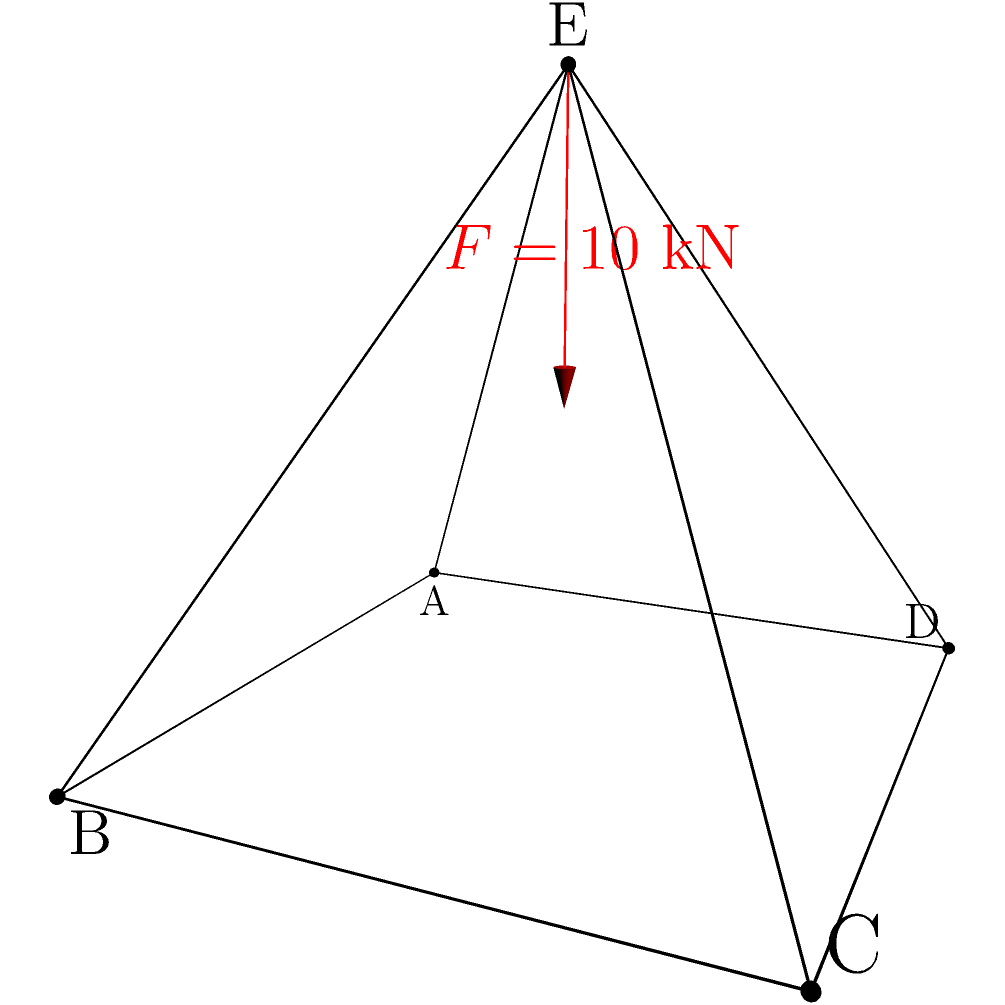Consider the space frame structure shown in the figure, where ABCD forms a square base of side length 3 meters, and point E is located 2 meters above the center of the square. A vertical force $F = 10$ kN is applied at point E, directed downwards. Using the method of virtual work, determine the vertical displacement of point E, assuming all members have the same cross-sectional area $A = 500$ mm² and Young's modulus $E = 200$ GPa. To solve this problem using the method of virtual work, we'll follow these steps:

1) First, we need to calculate the length of each member:
   Base members: $l_{AB} = l_{BC} = l_{CD} = l_{DA} = 3$ m
   Diagonal members: $l_{AE} = l_{BE} = l_{CE} = l_{DE} = \sqrt{3^2/2 + 2^2} = \sqrt{6.25} = 2.5$ m

2) Next, we'll apply a unit virtual force at point E in the direction of the displacement we want to calculate (vertical downward).

3) Now, we need to determine the axial forces in each member due to the real load (10 kN) and the virtual unit load.

   For the real load:
   Force in each diagonal member: $F_d = 10 / 4 = 2.5$ kN (tension)
   Force in base members: $F_b = 0$ kN

   For the virtual unit load:
   Virtual force in each diagonal member: $f_d = 1 / 4 = 0.25$ (tension)
   Virtual force in base members: $f_b = 0$

4) Apply the virtual work equation:
   $$\delta = \sum \frac{Ff l}{AE}$$
   where $\delta$ is the displacement, $F$ is the real force, $f$ is the virtual force, $l$ is the member length, $A$ is the cross-sectional area, and $E$ is Young's modulus.

5) Substituting the values:
   $$\delta = 4 \cdot \frac{2.5 \cdot 0.25 \cdot 2.5}{500 \cdot 10^{-6} \cdot 200 \cdot 10^9}$$

6) Simplify:
   $$\delta = 4 \cdot \frac{1.5625}{100 \cdot 10^6} = \frac{6.25}{100 \cdot 10^6} = 0.0625 \cdot 10^{-3} = 6.25 \cdot 10^{-5}$$ m

Therefore, the vertical displacement of point E is 0.0625 mm or 6.25 × 10⁻⁵ m downward.
Answer: 6.25 × 10⁻⁵ m downward 